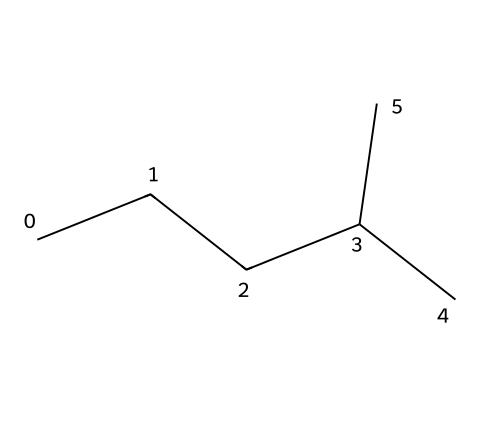What is the total number of carbon atoms in this compound? The provided SMILES representation "CCCC(C)C" indicates a linear chain of carbon atoms, with branching. By counting the 'C's in the structure, we can identify that there are a total of 6 carbon atoms.
Answer: 6 What type of hydrocarbon is represented by this SMILES? The SMILES notation indicates that this compound contains only carbon and hydrogen atoms with no double or triple bonds, indicating it is a saturated hydrocarbon. Therefore, this compound is classified as an alkane.
Answer: alkane How many hydrogen atoms are in this compound? In an alkane, the general formula is CnH(2n+2). Here, n = 6 (from 6 carbon atoms), so substituting gives us H(2*6+2) = H14. This means there are 14 hydrogen atoms present.
Answer: 14 Is this compound branched or straight-chain? The presence of a branching point (indicated in the SMILES by the "(C)" after "CCCC") means that the compound is not a straight-chain hydrocarbon but a branched one.
Answer: branched What is the molecular formula of this compound? Knowing the number of carbon (C) and hydrogen (H) atoms from previous answers (6 carbons and 14 hydrogens), we can write the molecular formula as C6H14, representing the composition of the compound.
Answer: C6H14 What might be a physical property of this compound relevant for rocket fuel? Alkanes like this compound tend to have relatively low boiling points and high volatility, which are essential properties for effective combustion in rocket fuels.
Answer: low boiling point Does this compound contain any functional groups? The SMILES representation does not display any functional groups as it only indicates carbon and hydrogen. Therefore, this compound is solely composed of aliphatic hydrocarbons without functional groups.
Answer: no 